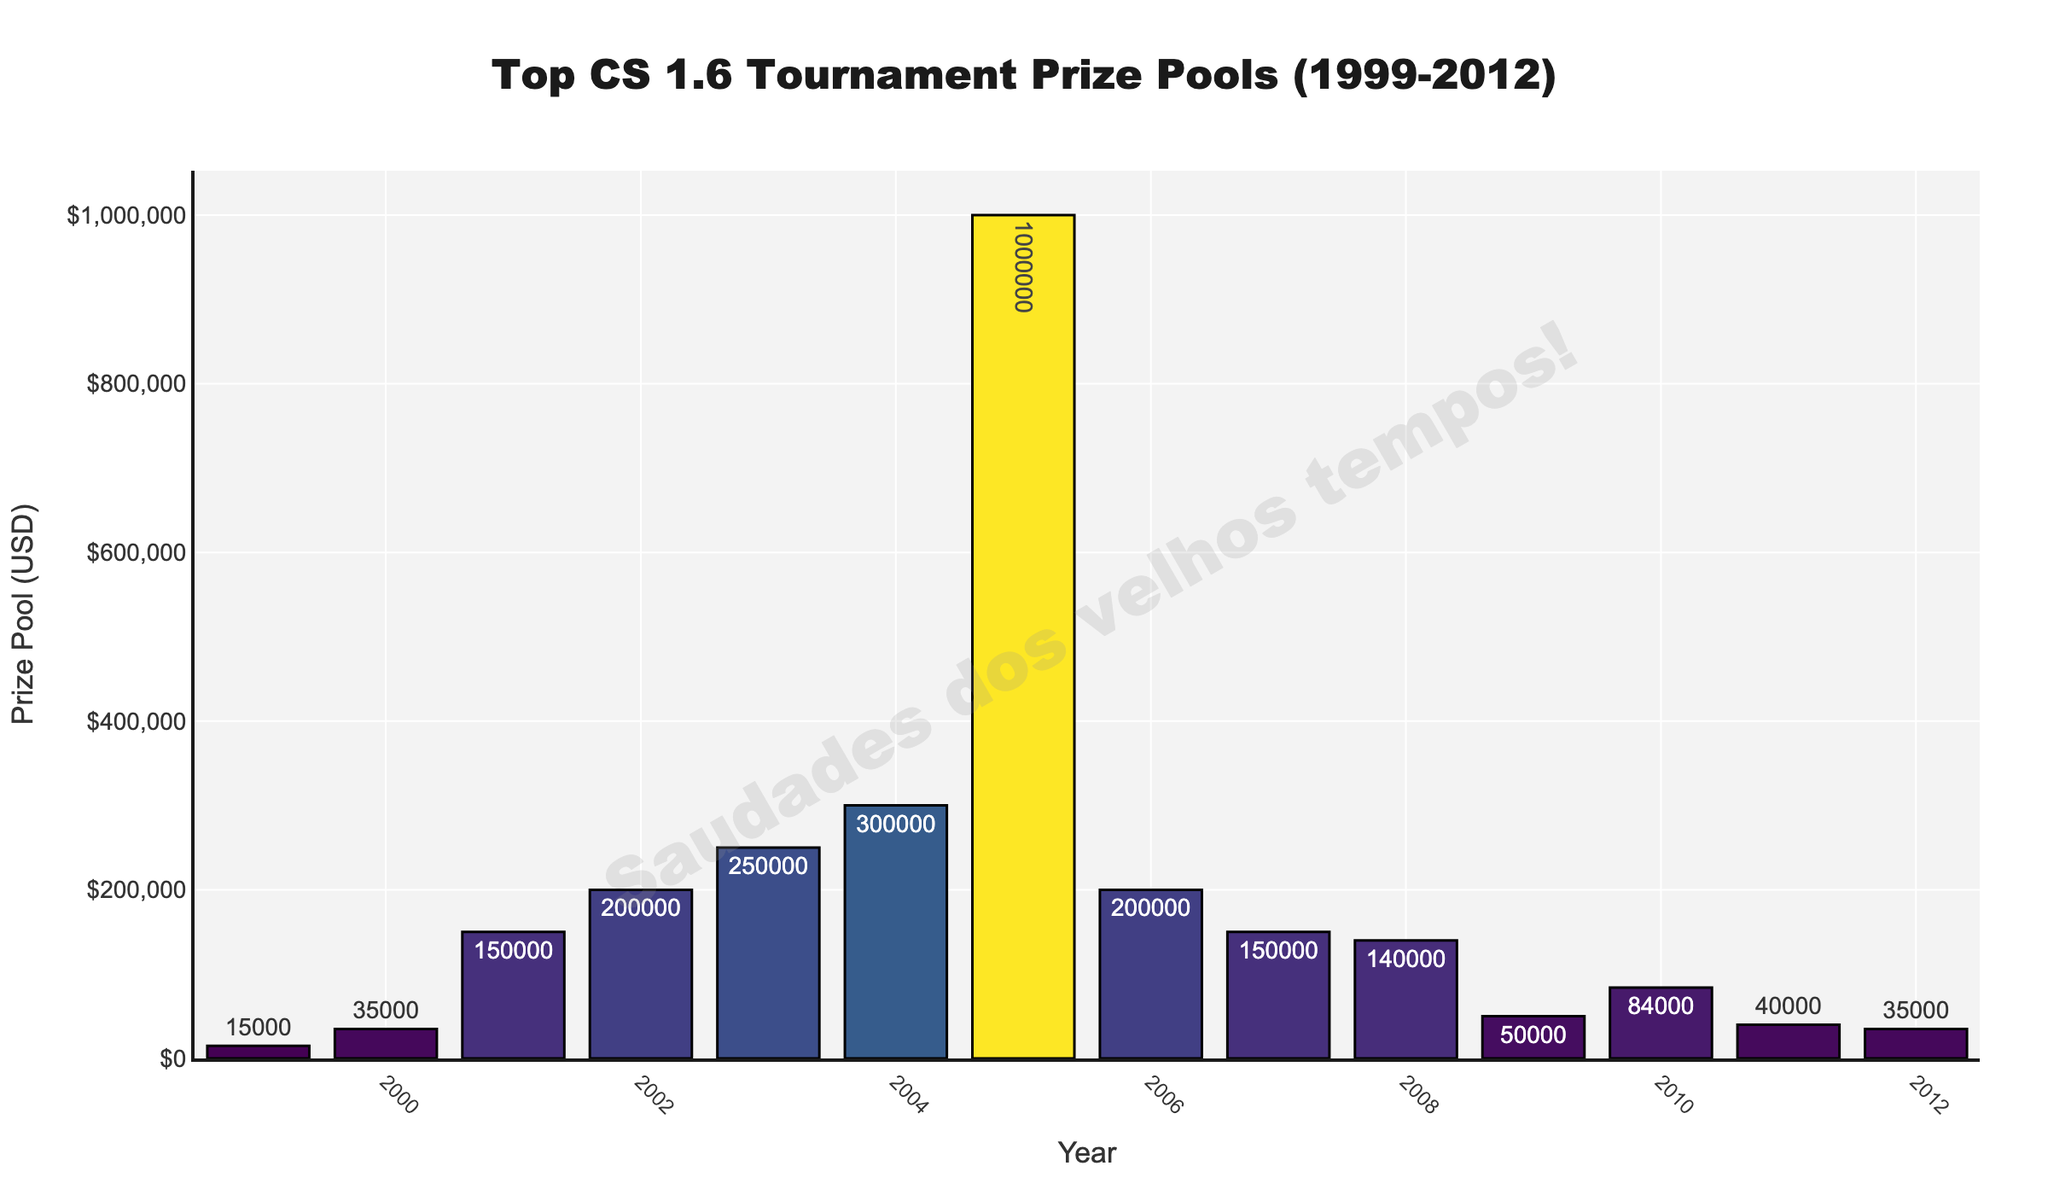Which year had the highest prize pool? The year with the highest prize pool can be identified by finding the tallest bar in the chart.
Answer: 2005 How did the prize pool change from 1999 to 2000? Observe the height difference between the bars for 1999 and 2000. The prize pool increased from $15,000 to $35,000.
Answer: Increased by $20,000 Which tournament had the lowest prize pool? The tournament with the lowest prize pool corresponds to the shortest bar, which is CPL Frag3 in 1999.
Answer: CPL Frag3 What is the difference between the highest and the lowest prize pools? Identify the highest prize pool ($1,000,000 in 2005) and the lowest prize pool ($15,000 in 1999), and subtract the lowest from the highest.
Answer: $985,000 How many tournaments had a prize pool of $150,000? Count the number of bars with a height corresponding to $150,000. There are two such bars (2001 and 2007).
Answer: 2 When did the prize pool first surpass $100,000? Locate the first year in which the bar height corresponds to a prize pool greater than $100,000. This happened in 2001.
Answer: 2001 What is the average prize pool across all the years? Sum the prize pools for all years and divide by the number of years (14). The calculation is (15000 + 35000 + 150000 + 200000 + 250000 + 300000 + 1000000 + 200000 + 150000 + 140000 + 50000 + 84000 + 40000 + 35000) / 14.
Answer: $175,714.29 How did the prize pool change between 2003 and 2004? Compare the bars for 2003 ($250,000) and 2004 ($300,000). The prize pool increased.
Answer: Increased by $50,000 